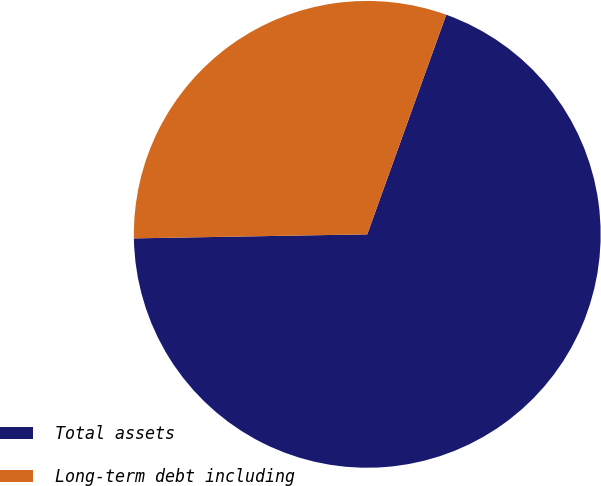Convert chart. <chart><loc_0><loc_0><loc_500><loc_500><pie_chart><fcel>Total assets<fcel>Long-term debt including<nl><fcel>69.23%<fcel>30.77%<nl></chart> 